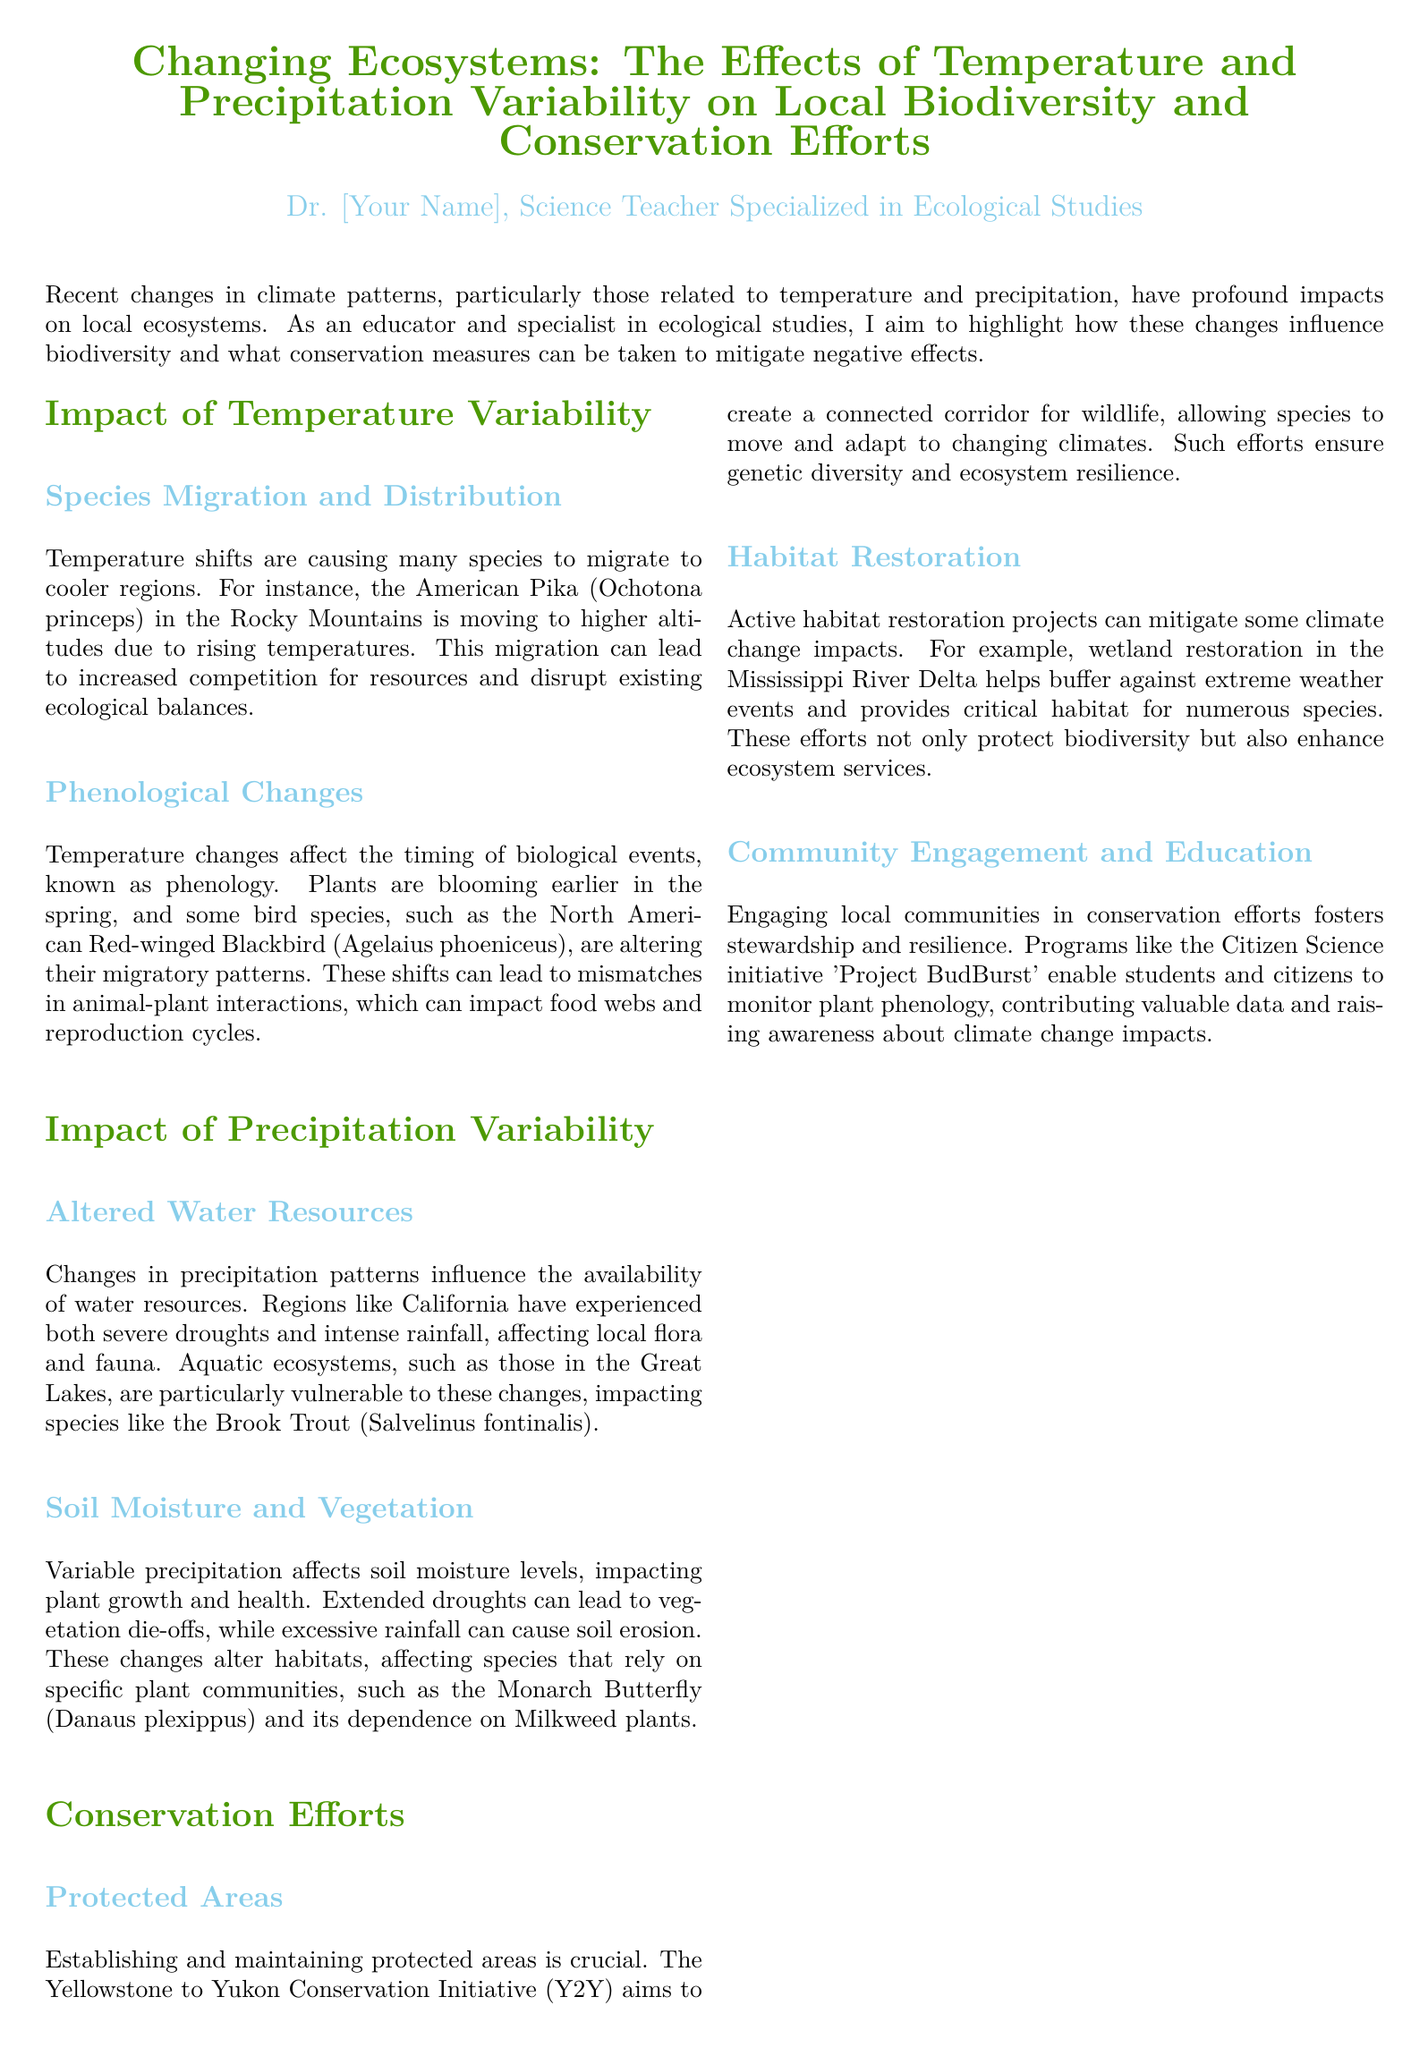What is the title of the whitepaper? The title of the whitepaper is explicitly stated at the beginning of the document.
Answer: Changing Ecosystems: The Effects of Temperature and Precipitation Variability on Local Biodiversity and Conservation Efforts Who is the author of the document? The author is introduced in the document with a specific title.
Answer: Dr. [Your Name] What species is mentioned as migrating to higher altitudes? The document provides an example of a specific species affected by temperature shifts.
Answer: American Pika What conservation initiative aims to create a connected corridor for wildlife? The document lists a specific conservation initiative as an example of conservation efforts.
Answer: Yellowstone to Yukon Conservation Initiative (Y2Y) Which butterfly species is dependent on Milkweed plants? The document highlights a species that relies on specific plants for its survival.
Answer: Monarch Butterfly What phenomenon describes the timing of biological events affected by temperature changes? The document explains a term that refers to the timing of biological events.
Answer: Phenology What is cited as a community engagement initiative to monitor plant phenology? The document provides a specific project that involves community participation and data collection.
Answer: Project BudBurst What impacts can extended droughts have on vegetation? The whitepaper discusses consequences of precipitation variability related to prolonged dry conditions.
Answer: Die-offs How does habitat restoration help mitigate climate change impacts? The document explains the benefits of restoring specific habitats in terms of ecosystems and biodiversity.
Answer: Buffers against extreme weather events 